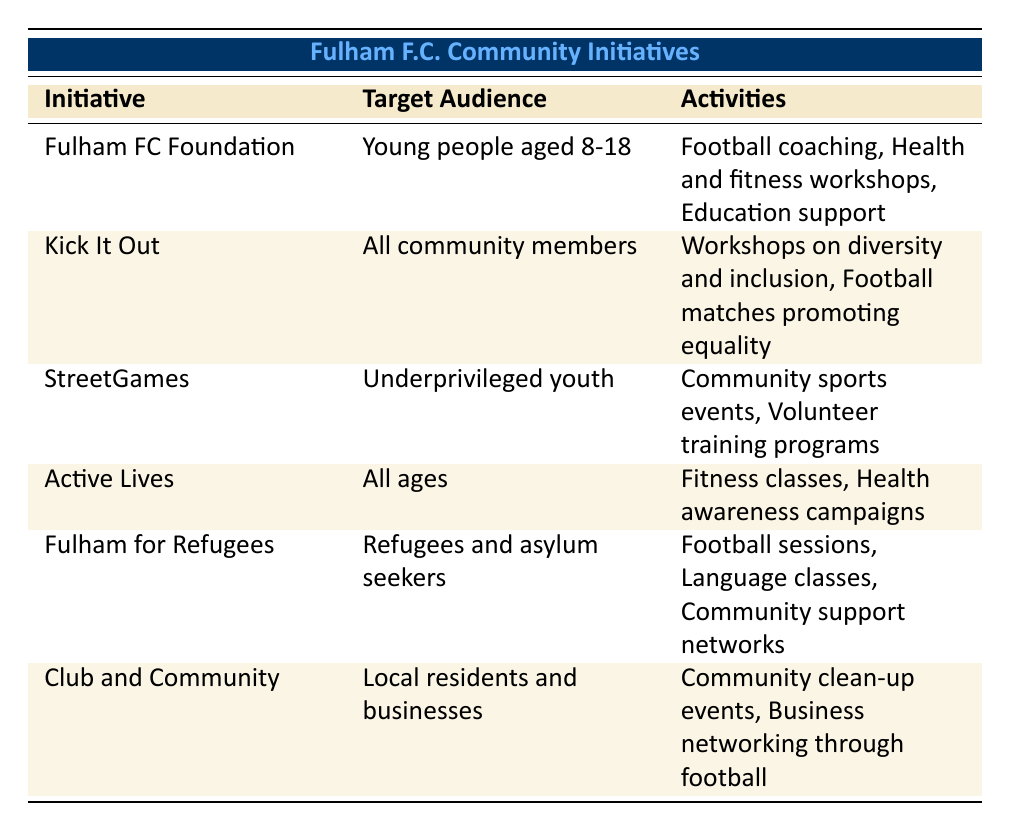What is the target audience for the Fulham FC Foundation? The table lists the target audience for the Fulham FC Foundation as "Young people aged 8-18."
Answer: Young people aged 8-18 How many initiatives target all ages? The initiative "Active Lives" is specifically targeted at "All ages." The other initiatives either target specific age groups or populations. Therefore, in total, there is only one initiative targeting all ages.
Answer: 1 Is "Kick It Out" aimed at young people aged 8-18? The target audience for "Kick It Out" is listed as "All community members," which includes various age groups including young people, but it does not specifically focus on just young people aged 8-18.
Answer: No What activities does "Fulham for Refugees" offer? According to the table, "Fulham for Refugees" offers "Football sessions," "Language classes," and "Community support networks."
Answer: Football sessions, Language classes, Community support networks Which initiative has partnerships with local schools? The "Fulham FC Foundation" has partnerships with "London Borough of Hammersmith and Fulham" and "Local schools," as indicated in the table.
Answer: Fulham FC Foundation Which community initiative includes “Community clean-up events”? The initiative titled "Club and Community" includes "Community clean-up events" as one of its activities, as shown in the table.
Answer: Club and Community How many initiatives target underprivileged youth? The initiative "StreetGames" is the only one specifically aimed at "Underprivileged youth," indicating there is only one initiative targeting this demographic.
Answer: 1 Is there a program that focuses on promoting equality? Yes, the initiative "Kick It Out" specifically aims at tackling discrimination and promoting equality in football, as stated in the table.
Answer: Yes What is the common theme among partnerships of the "Fulham for Refugees"? The partnerships for "Fulham for Refugees" include organizations like "Refugee Council" and "Local charities," which share a theme of supporting refugees and asylum seekers in the community.
Answer: Support for refugees and asylum seekers 